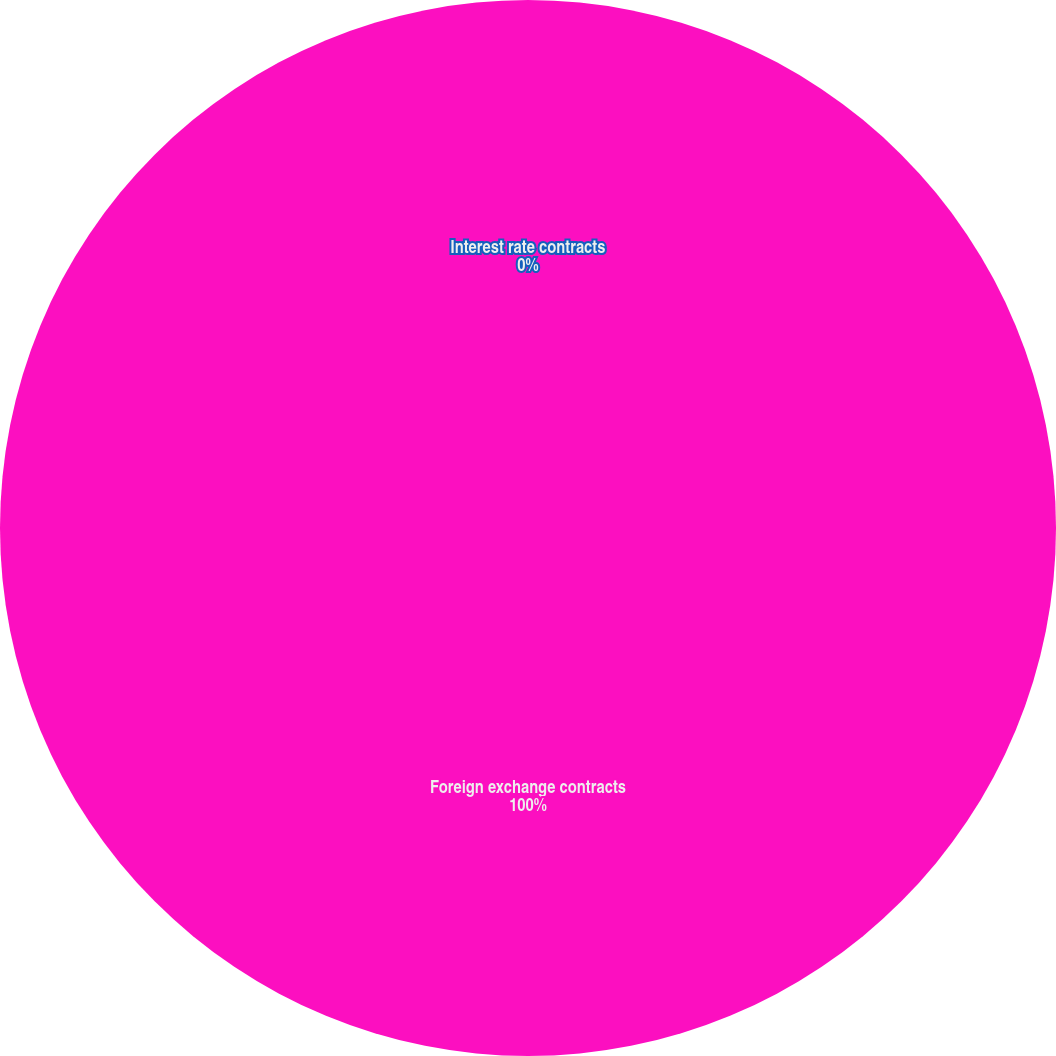Convert chart. <chart><loc_0><loc_0><loc_500><loc_500><pie_chart><fcel>Foreign exchange contracts<fcel>Interest rate contracts<nl><fcel>100.0%<fcel>0.0%<nl></chart> 